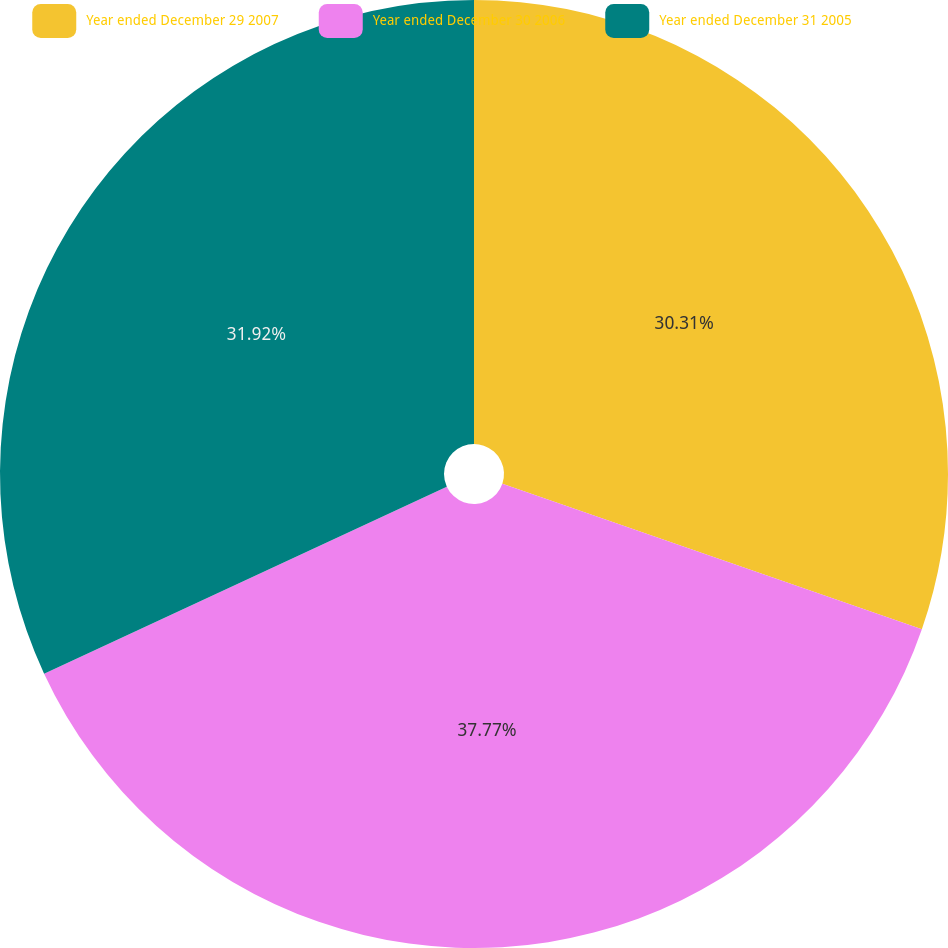Convert chart. <chart><loc_0><loc_0><loc_500><loc_500><pie_chart><fcel>Year ended December 29 2007<fcel>Year ended December 30 2006<fcel>Year ended December 31 2005<nl><fcel>30.31%<fcel>37.77%<fcel>31.92%<nl></chart> 